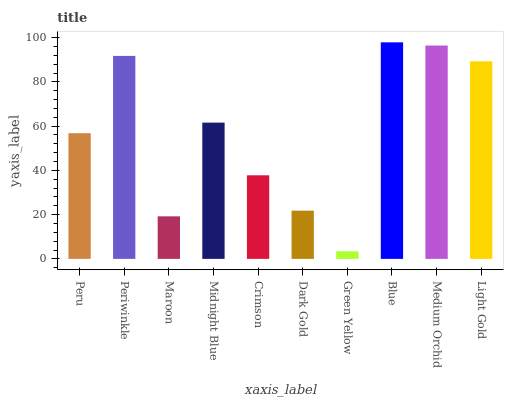Is Green Yellow the minimum?
Answer yes or no. Yes. Is Blue the maximum?
Answer yes or no. Yes. Is Periwinkle the minimum?
Answer yes or no. No. Is Periwinkle the maximum?
Answer yes or no. No. Is Periwinkle greater than Peru?
Answer yes or no. Yes. Is Peru less than Periwinkle?
Answer yes or no. Yes. Is Peru greater than Periwinkle?
Answer yes or no. No. Is Periwinkle less than Peru?
Answer yes or no. No. Is Midnight Blue the high median?
Answer yes or no. Yes. Is Peru the low median?
Answer yes or no. Yes. Is Crimson the high median?
Answer yes or no. No. Is Crimson the low median?
Answer yes or no. No. 